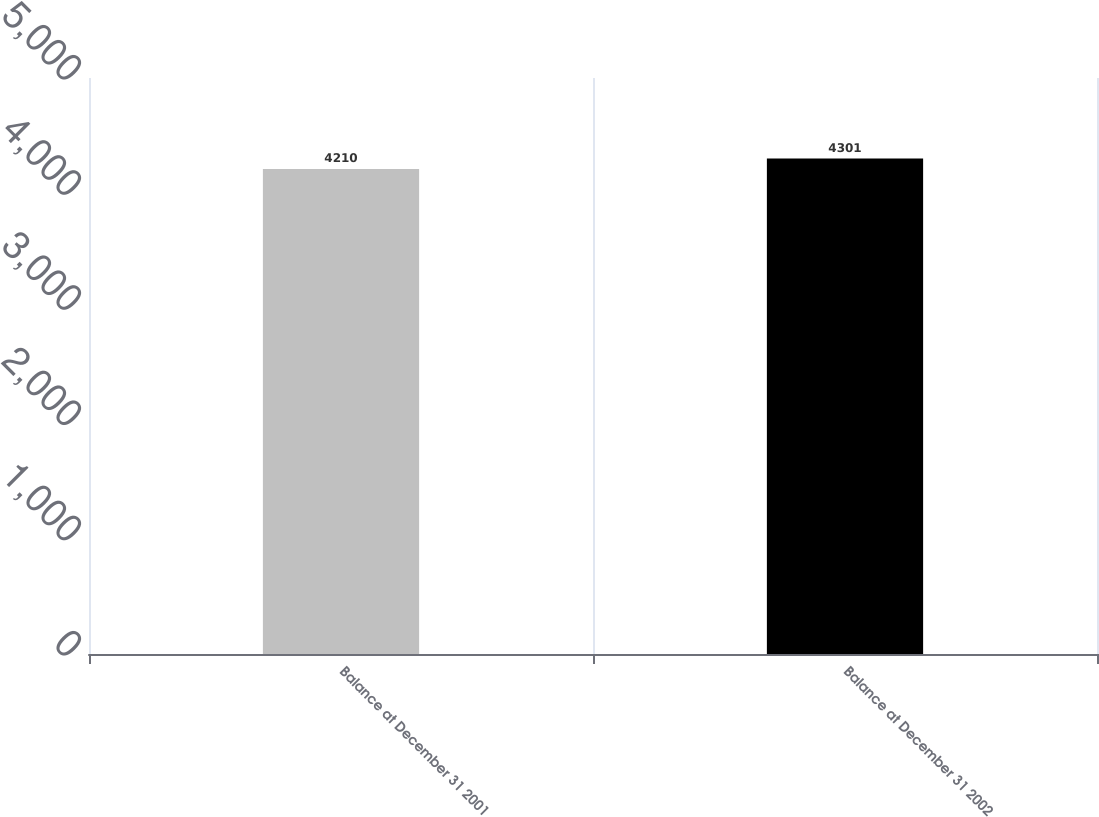<chart> <loc_0><loc_0><loc_500><loc_500><bar_chart><fcel>Balance at December 31 2001<fcel>Balance at December 31 2002<nl><fcel>4210<fcel>4301<nl></chart> 